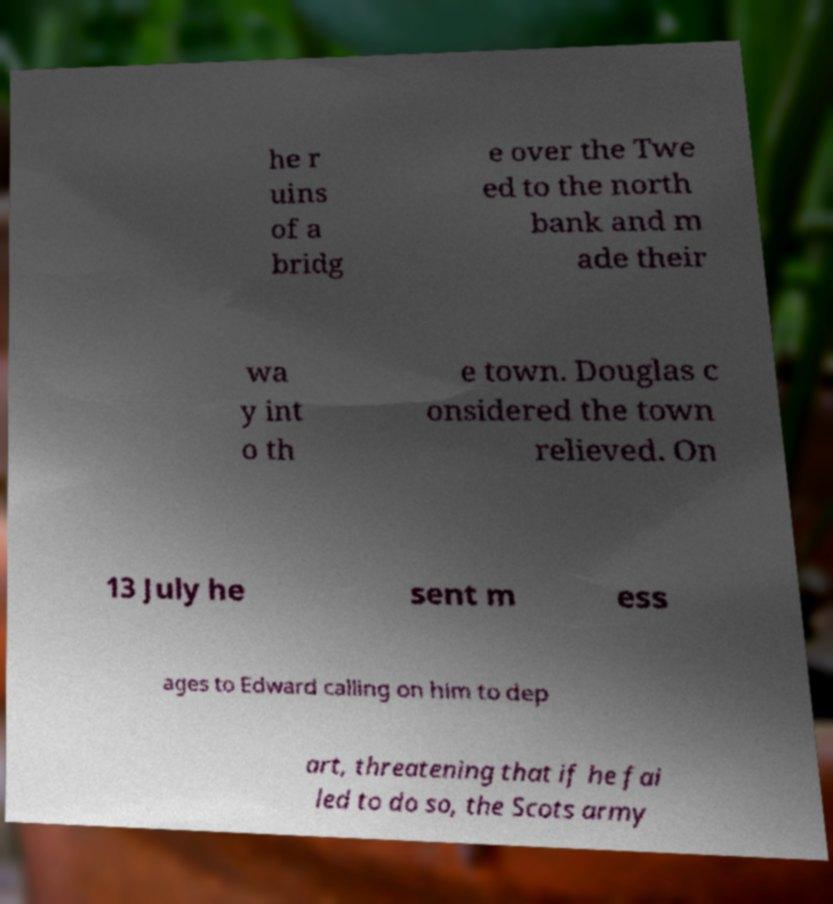Could you assist in decoding the text presented in this image and type it out clearly? he r uins of a bridg e over the Twe ed to the north bank and m ade their wa y int o th e town. Douglas c onsidered the town relieved. On 13 July he sent m ess ages to Edward calling on him to dep art, threatening that if he fai led to do so, the Scots army 